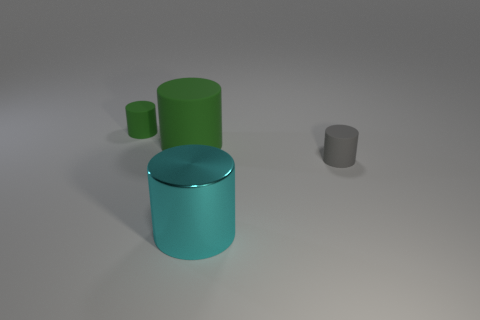There is a thing that is left of the tiny gray rubber cylinder and to the right of the big green cylinder; how big is it?
Keep it short and to the point. Large. What number of other things have the same material as the big cyan thing?
Make the answer very short. 0. What shape is the small thing that is the same color as the large matte thing?
Your answer should be compact. Cylinder. What color is the shiny cylinder?
Your answer should be very brief. Cyan. Does the tiny thing that is to the right of the big metallic cylinder have the same shape as the large cyan metallic thing?
Offer a very short reply. Yes. How many objects are rubber cylinders to the right of the big cyan object or tiny gray matte cylinders?
Give a very brief answer. 1. Are there any big objects that have the same shape as the tiny gray matte thing?
Make the answer very short. Yes. There is a green object that is the same size as the gray cylinder; what is its shape?
Offer a terse response. Cylinder. What shape is the thing that is left of the green object that is in front of the small thing that is to the left of the big matte cylinder?
Your answer should be compact. Cylinder. There is a cyan shiny thing; does it have the same shape as the thing behind the large matte thing?
Your answer should be compact. Yes. 